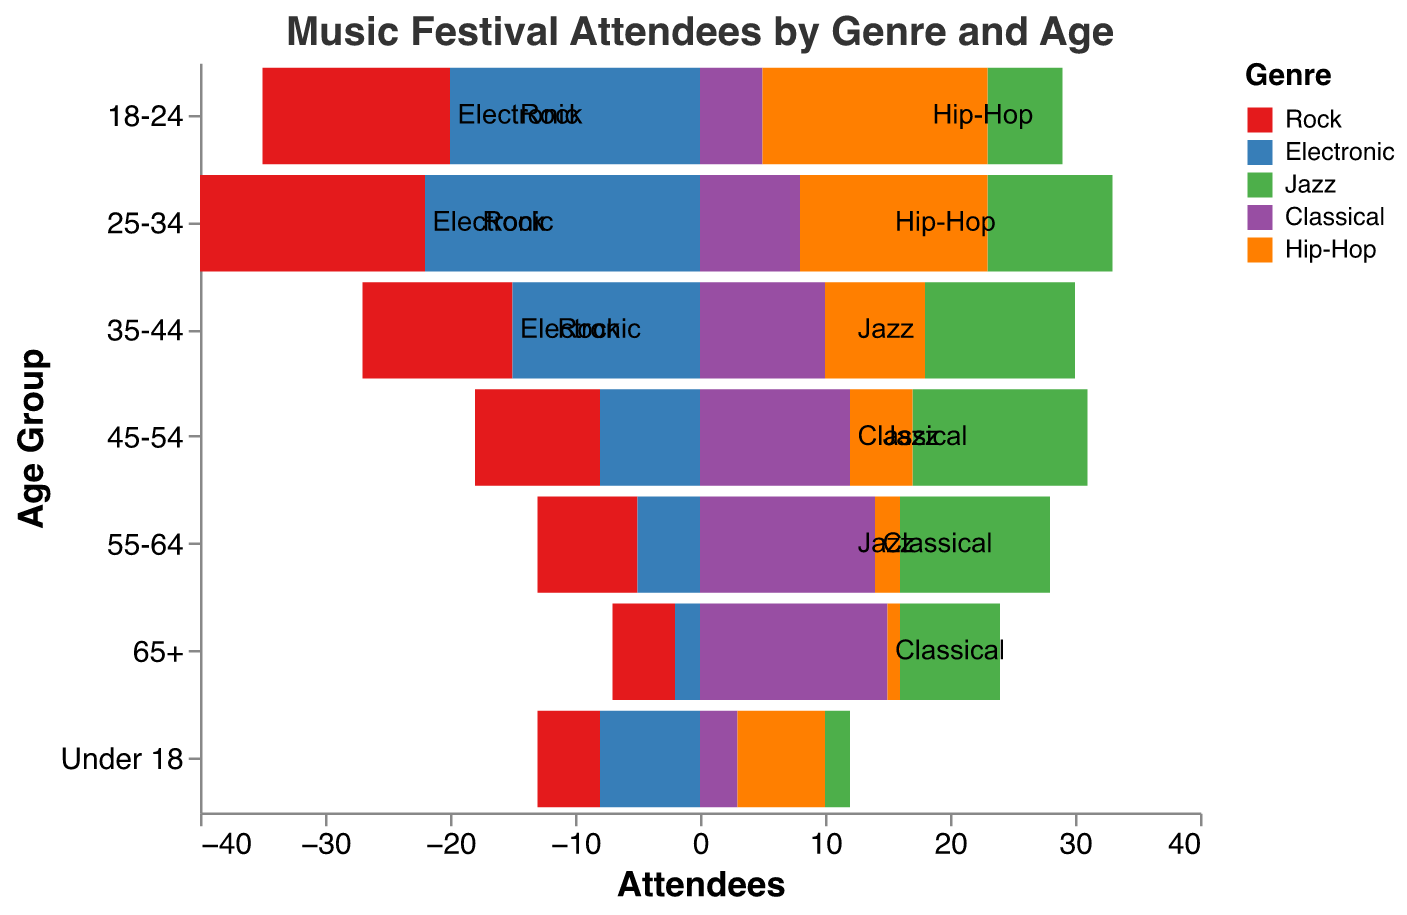What is the most attended genre among the 18-24 age group? Look at the segments in the '18-24' age group and identify the tallest bar; the 'Electronic' genre has the highest attendee count.
Answer: Electronic How many attendees are there for Jazz and Classical music combined in the 55-64 age group? Find the attendee count for Jazz (12) and Classical (14) in the '55-64' age group and add them together: 12 + 14 = 26
Answer: 26 Which genre has more attendees in the 25-34 age group, Rock or Hip-Hop? Compare the bar lengths for Rock (18) and Hip-Hop (15) in the '25-34' age group; Rock has more attendees.
Answer: Rock What is the trend of Classical music attendance as the age increases? Observe the lengths of the bars for Classical across age groups; Classical attendance increases with age.
Answer: Increases Which age group has the lowest number of Hip-Hop attendees? Identify the smallest bar in the 'Hip-Hop' genre; the '65+' age group has the lowest attendance with 1 attendee.
Answer: 65+ Is the number of attendees for Electronic music greater in the 18-24 or 25-34 age group? Compare the bar lengths for Electronic in the '18-24' (20 attendees) and '25-34' (22 attendees) age groups; '25-34' has more attendees.
Answer: 25-34 How does the attendance for Jazz music in the 35-44 age group compare to that in the 45-54 age group? Compare the bar lengths for Jazz in the '35-44' (12 attendees) and '45-54' (14 attendees) age groups; '45-54' has more attendees.
Answer: 45-54 What is the total number of Classical music attendees across all age groups? Sum the attendees for Classical in all age groups: 3 (Under 18) + 5 (18-24) + 8 (25-34) + 10 (35-44) + 12 (45-54) + 14 (55-64) + 15 (65+) = 67
Answer: 67 Which genre has the smallest number of total attendees? Sum the attendees for each genre across all age groups and identify the smallest sum; Jazz has the smallest number: 2 + 6 + 10 + 12 + 14 + 12 + 8 = 64
Answer: Jazz 